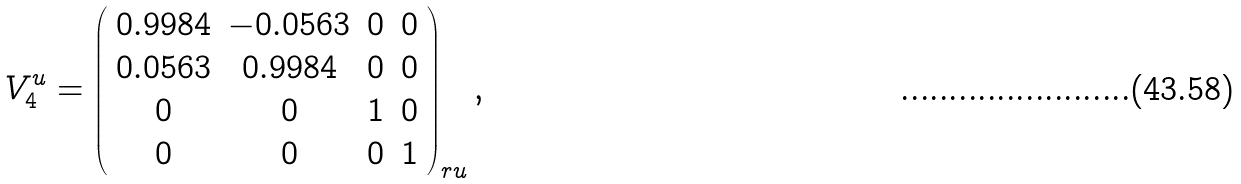<formula> <loc_0><loc_0><loc_500><loc_500>V _ { 4 } ^ { u } = \left ( \begin{array} { c c c c } 0 . 9 9 8 4 & - 0 . 0 5 6 3 & 0 & 0 \\ 0 . 0 5 6 3 & 0 . 9 9 8 4 & 0 & 0 \\ 0 & 0 & 1 & 0 \\ 0 & 0 & 0 & 1 \end{array} \right ) _ { r u } ,</formula> 